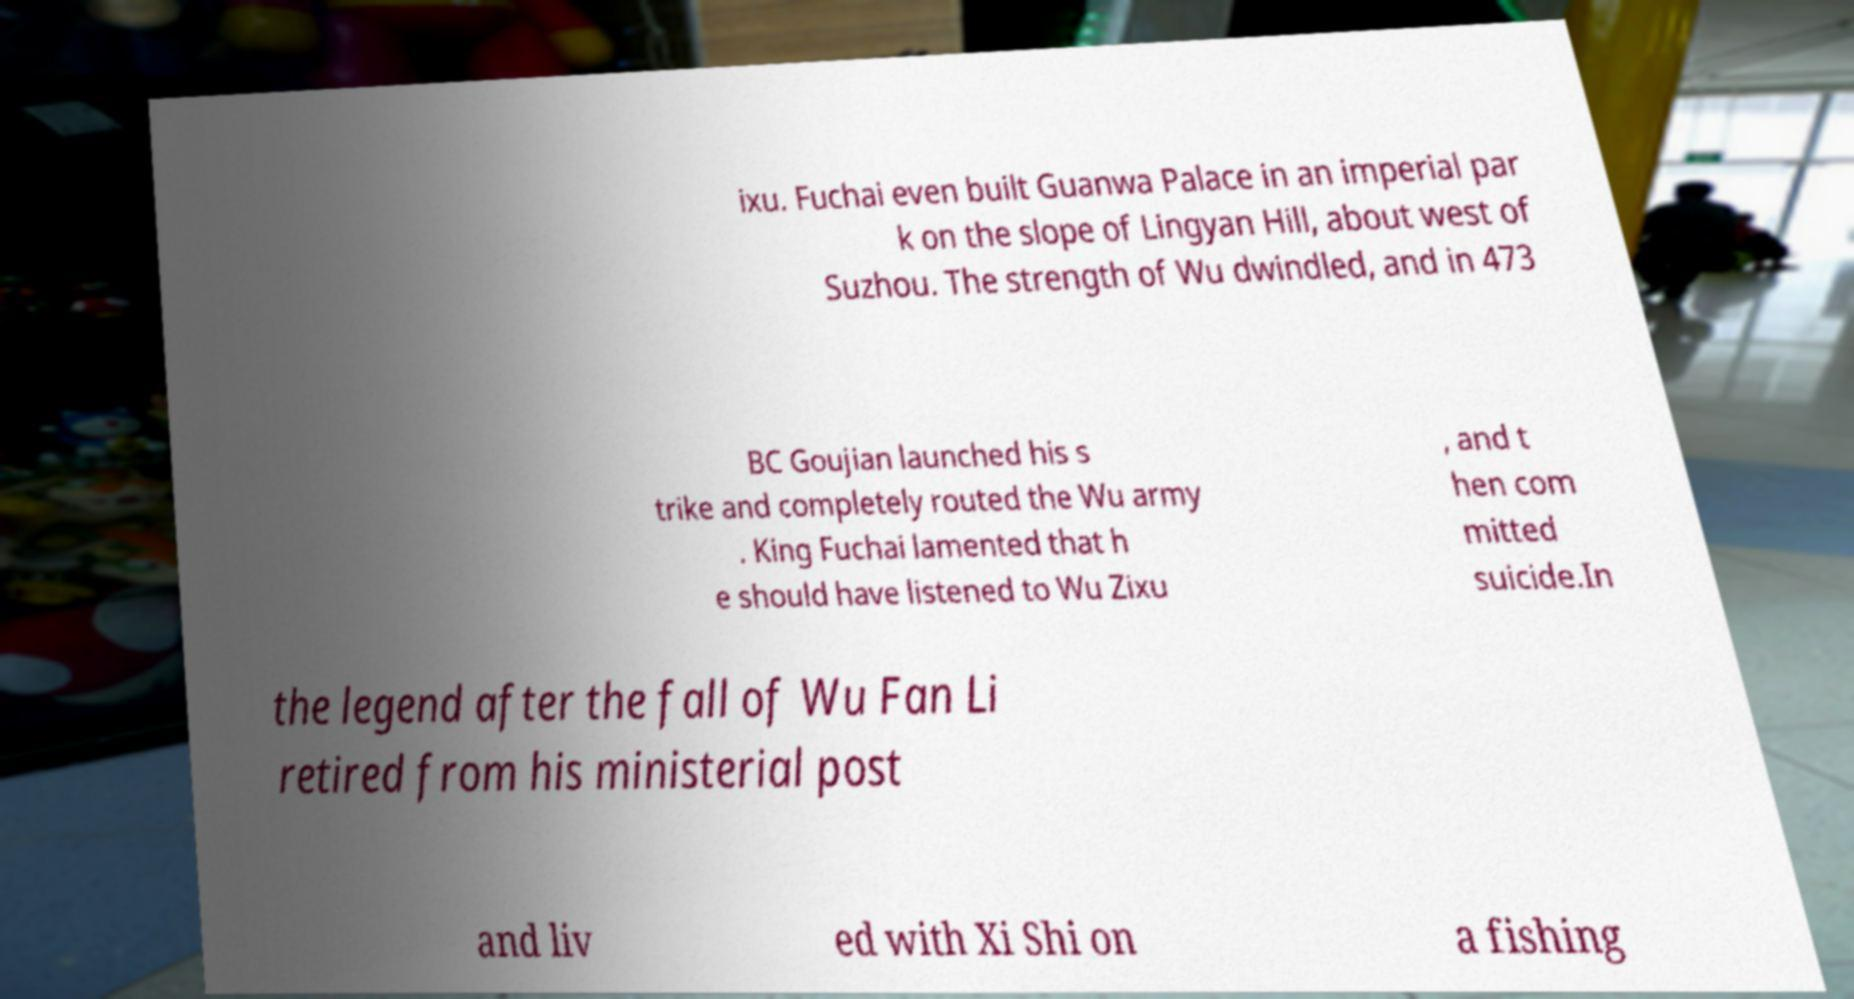There's text embedded in this image that I need extracted. Can you transcribe it verbatim? ixu. Fuchai even built Guanwa Palace in an imperial par k on the slope of Lingyan Hill, about west of Suzhou. The strength of Wu dwindled, and in 473 BC Goujian launched his s trike and completely routed the Wu army . King Fuchai lamented that h e should have listened to Wu Zixu , and t hen com mitted suicide.In the legend after the fall of Wu Fan Li retired from his ministerial post and liv ed with Xi Shi on a fishing 